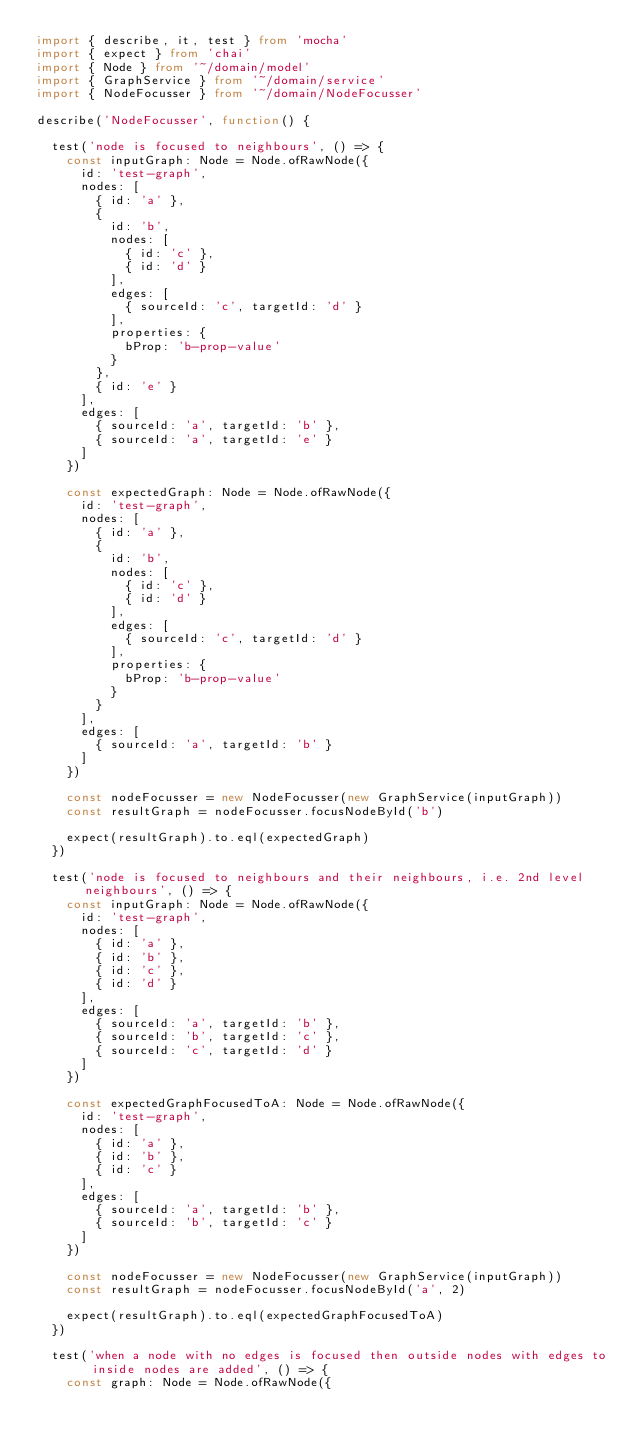<code> <loc_0><loc_0><loc_500><loc_500><_TypeScript_>import { describe, it, test } from 'mocha'
import { expect } from 'chai'
import { Node } from '~/domain/model'
import { GraphService } from '~/domain/service'
import { NodeFocusser } from '~/domain/NodeFocusser'

describe('NodeFocusser', function() {

  test('node is focused to neighbours', () => {
    const inputGraph: Node = Node.ofRawNode({
      id: 'test-graph',
      nodes: [
        { id: 'a' },
        {
          id: 'b',
          nodes: [
            { id: 'c' },
            { id: 'd' }
          ],
          edges: [
            { sourceId: 'c', targetId: 'd' }
          ],
          properties: {
            bProp: 'b-prop-value'
          }
        },
        { id: 'e' }
      ],
      edges: [
        { sourceId: 'a', targetId: 'b' },
        { sourceId: 'a', targetId: 'e' }
      ]
    })

    const expectedGraph: Node = Node.ofRawNode({
      id: 'test-graph',
      nodes: [
        { id: 'a' },
        {
          id: 'b',
          nodes: [
            { id: 'c' },
            { id: 'd' }
          ],
          edges: [
            { sourceId: 'c', targetId: 'd' }
          ],
          properties: {
            bProp: 'b-prop-value'
          }
        }
      ],
      edges: [
        { sourceId: 'a', targetId: 'b' }
      ]
    })

    const nodeFocusser = new NodeFocusser(new GraphService(inputGraph))
    const resultGraph = nodeFocusser.focusNodeById('b')

    expect(resultGraph).to.eql(expectedGraph)
  })

  test('node is focused to neighbours and their neighbours, i.e. 2nd level neighbours', () => {
    const inputGraph: Node = Node.ofRawNode({
      id: 'test-graph',
      nodes: [
        { id: 'a' },
        { id: 'b' },
        { id: 'c' },
        { id: 'd' }
      ],
      edges: [
        { sourceId: 'a', targetId: 'b' },
        { sourceId: 'b', targetId: 'c' },
        { sourceId: 'c', targetId: 'd' }
      ]
    })

    const expectedGraphFocusedToA: Node = Node.ofRawNode({
      id: 'test-graph',
      nodes: [
        { id: 'a' },
        { id: 'b' },
        { id: 'c' }
      ],
      edges: [
        { sourceId: 'a', targetId: 'b' },
        { sourceId: 'b', targetId: 'c' }
      ]
    })

    const nodeFocusser = new NodeFocusser(new GraphService(inputGraph))
    const resultGraph = nodeFocusser.focusNodeById('a', 2)

    expect(resultGraph).to.eql(expectedGraphFocusedToA)
  })

  test('when a node with no edges is focused then outside nodes with edges to inside nodes are added', () => {
    const graph: Node = Node.ofRawNode({</code> 